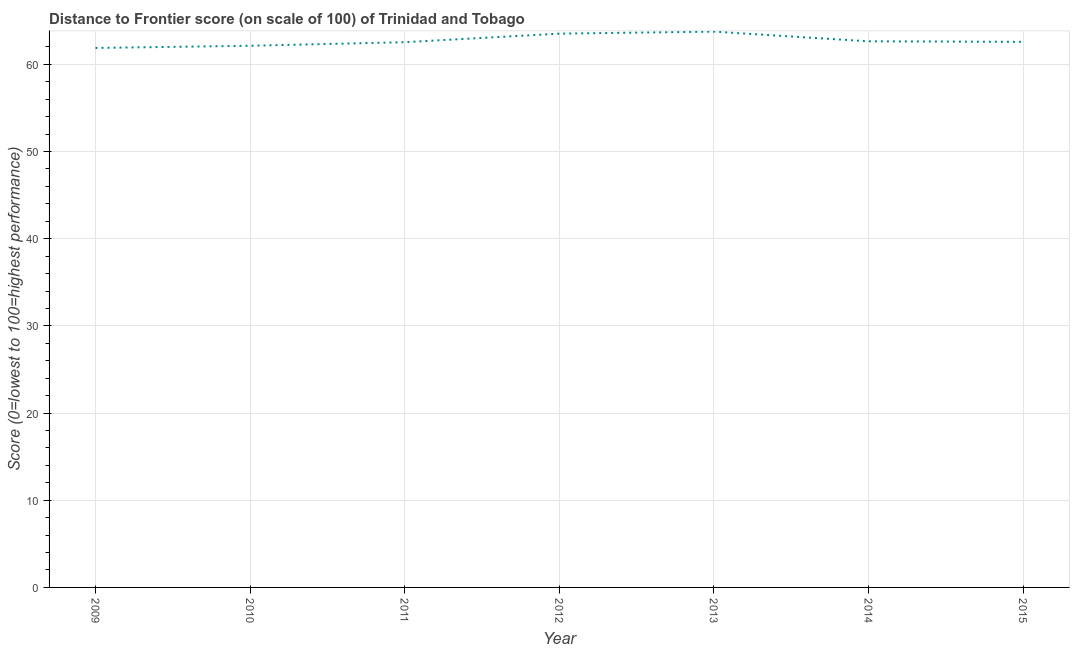What is the distance to frontier score in 2015?
Offer a very short reply. 62.58. Across all years, what is the maximum distance to frontier score?
Your response must be concise. 63.75. Across all years, what is the minimum distance to frontier score?
Your answer should be compact. 61.88. What is the sum of the distance to frontier score?
Provide a short and direct response. 439.04. What is the difference between the distance to frontier score in 2009 and 2013?
Your response must be concise. -1.87. What is the average distance to frontier score per year?
Provide a succinct answer. 62.72. What is the median distance to frontier score?
Your response must be concise. 62.58. In how many years, is the distance to frontier score greater than 58 ?
Your response must be concise. 7. What is the ratio of the distance to frontier score in 2011 to that in 2015?
Provide a short and direct response. 1. Is the distance to frontier score in 2011 less than that in 2015?
Give a very brief answer. Yes. Is the difference between the distance to frontier score in 2011 and 2014 greater than the difference between any two years?
Your response must be concise. No. What is the difference between the highest and the second highest distance to frontier score?
Provide a succinct answer. 0.23. What is the difference between the highest and the lowest distance to frontier score?
Provide a succinct answer. 1.87. How many years are there in the graph?
Keep it short and to the point. 7. What is the difference between two consecutive major ticks on the Y-axis?
Your answer should be very brief. 10. What is the title of the graph?
Your answer should be very brief. Distance to Frontier score (on scale of 100) of Trinidad and Tobago. What is the label or title of the X-axis?
Offer a very short reply. Year. What is the label or title of the Y-axis?
Your answer should be very brief. Score (0=lowest to 100=highest performance). What is the Score (0=lowest to 100=highest performance) of 2009?
Your answer should be very brief. 61.88. What is the Score (0=lowest to 100=highest performance) of 2010?
Provide a short and direct response. 62.13. What is the Score (0=lowest to 100=highest performance) in 2011?
Provide a succinct answer. 62.54. What is the Score (0=lowest to 100=highest performance) of 2012?
Your answer should be very brief. 63.52. What is the Score (0=lowest to 100=highest performance) of 2013?
Your answer should be compact. 63.75. What is the Score (0=lowest to 100=highest performance) of 2014?
Ensure brevity in your answer.  62.64. What is the Score (0=lowest to 100=highest performance) in 2015?
Your answer should be very brief. 62.58. What is the difference between the Score (0=lowest to 100=highest performance) in 2009 and 2010?
Offer a very short reply. -0.25. What is the difference between the Score (0=lowest to 100=highest performance) in 2009 and 2011?
Give a very brief answer. -0.66. What is the difference between the Score (0=lowest to 100=highest performance) in 2009 and 2012?
Give a very brief answer. -1.64. What is the difference between the Score (0=lowest to 100=highest performance) in 2009 and 2013?
Ensure brevity in your answer.  -1.87. What is the difference between the Score (0=lowest to 100=highest performance) in 2009 and 2014?
Your answer should be very brief. -0.76. What is the difference between the Score (0=lowest to 100=highest performance) in 2009 and 2015?
Ensure brevity in your answer.  -0.7. What is the difference between the Score (0=lowest to 100=highest performance) in 2010 and 2011?
Your answer should be compact. -0.41. What is the difference between the Score (0=lowest to 100=highest performance) in 2010 and 2012?
Ensure brevity in your answer.  -1.39. What is the difference between the Score (0=lowest to 100=highest performance) in 2010 and 2013?
Keep it short and to the point. -1.62. What is the difference between the Score (0=lowest to 100=highest performance) in 2010 and 2014?
Provide a short and direct response. -0.51. What is the difference between the Score (0=lowest to 100=highest performance) in 2010 and 2015?
Keep it short and to the point. -0.45. What is the difference between the Score (0=lowest to 100=highest performance) in 2011 and 2012?
Make the answer very short. -0.98. What is the difference between the Score (0=lowest to 100=highest performance) in 2011 and 2013?
Your answer should be compact. -1.21. What is the difference between the Score (0=lowest to 100=highest performance) in 2011 and 2015?
Your answer should be very brief. -0.04. What is the difference between the Score (0=lowest to 100=highest performance) in 2012 and 2013?
Your answer should be compact. -0.23. What is the difference between the Score (0=lowest to 100=highest performance) in 2013 and 2014?
Provide a succinct answer. 1.11. What is the difference between the Score (0=lowest to 100=highest performance) in 2013 and 2015?
Offer a very short reply. 1.17. What is the ratio of the Score (0=lowest to 100=highest performance) in 2009 to that in 2010?
Ensure brevity in your answer.  1. What is the ratio of the Score (0=lowest to 100=highest performance) in 2009 to that in 2014?
Your answer should be very brief. 0.99. What is the ratio of the Score (0=lowest to 100=highest performance) in 2010 to that in 2011?
Make the answer very short. 0.99. What is the ratio of the Score (0=lowest to 100=highest performance) in 2010 to that in 2012?
Provide a short and direct response. 0.98. What is the ratio of the Score (0=lowest to 100=highest performance) in 2010 to that in 2014?
Your answer should be very brief. 0.99. What is the ratio of the Score (0=lowest to 100=highest performance) in 2011 to that in 2012?
Ensure brevity in your answer.  0.98. What is the ratio of the Score (0=lowest to 100=highest performance) in 2012 to that in 2013?
Keep it short and to the point. 1. What is the ratio of the Score (0=lowest to 100=highest performance) in 2013 to that in 2015?
Your answer should be very brief. 1.02. 